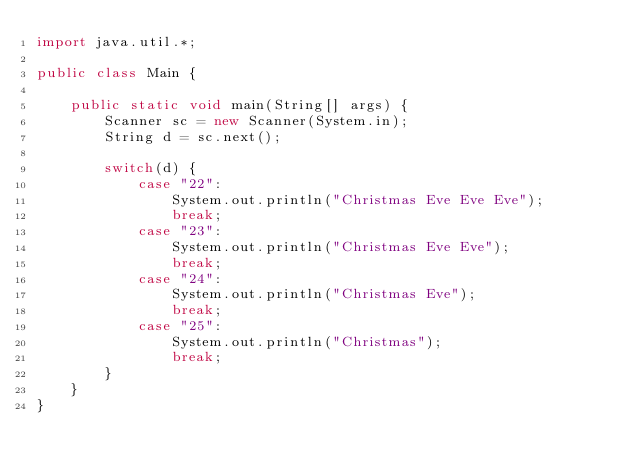Convert code to text. <code><loc_0><loc_0><loc_500><loc_500><_Java_>import java.util.*;

public class Main {

    public static void main(String[] args) {
        Scanner sc = new Scanner(System.in);
        String d = sc.next();

        switch(d) {
            case "22":
                System.out.println("Christmas Eve Eve Eve");
                break;
            case "23":
                System.out.println("Christmas Eve Eve");
                break;
            case "24":
                System.out.println("Christmas Eve");
                break;
            case "25":
                System.out.println("Christmas");
                break;
        }
    }
}</code> 